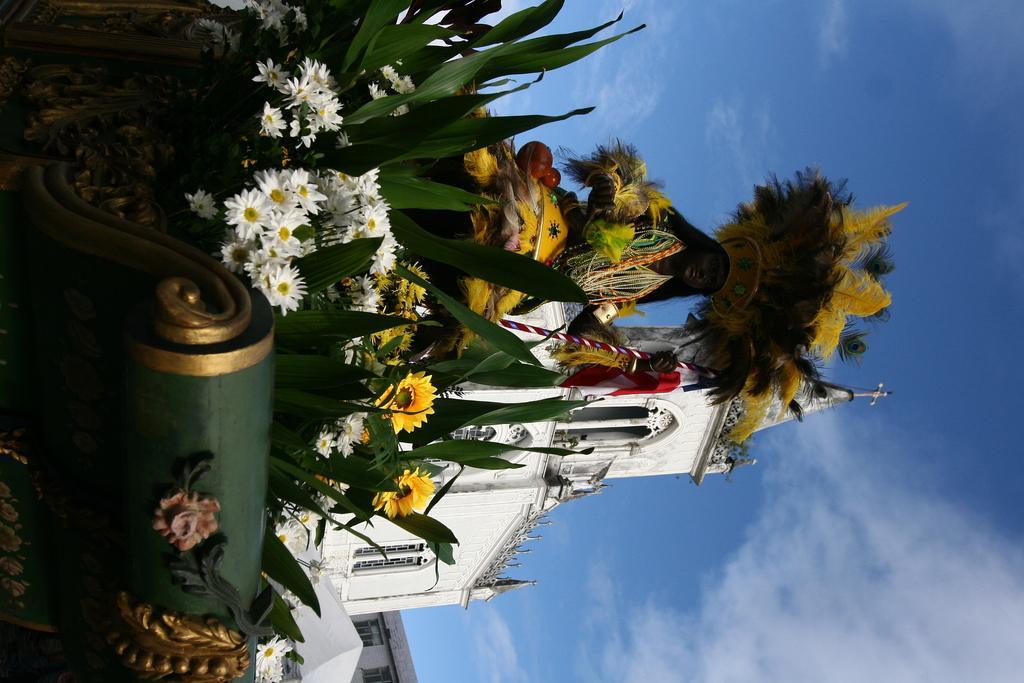How would you summarize this image in a sentence or two? In this image there is a person standing on the cart decorated with flowers and leaves, behind the person there is a church building. 